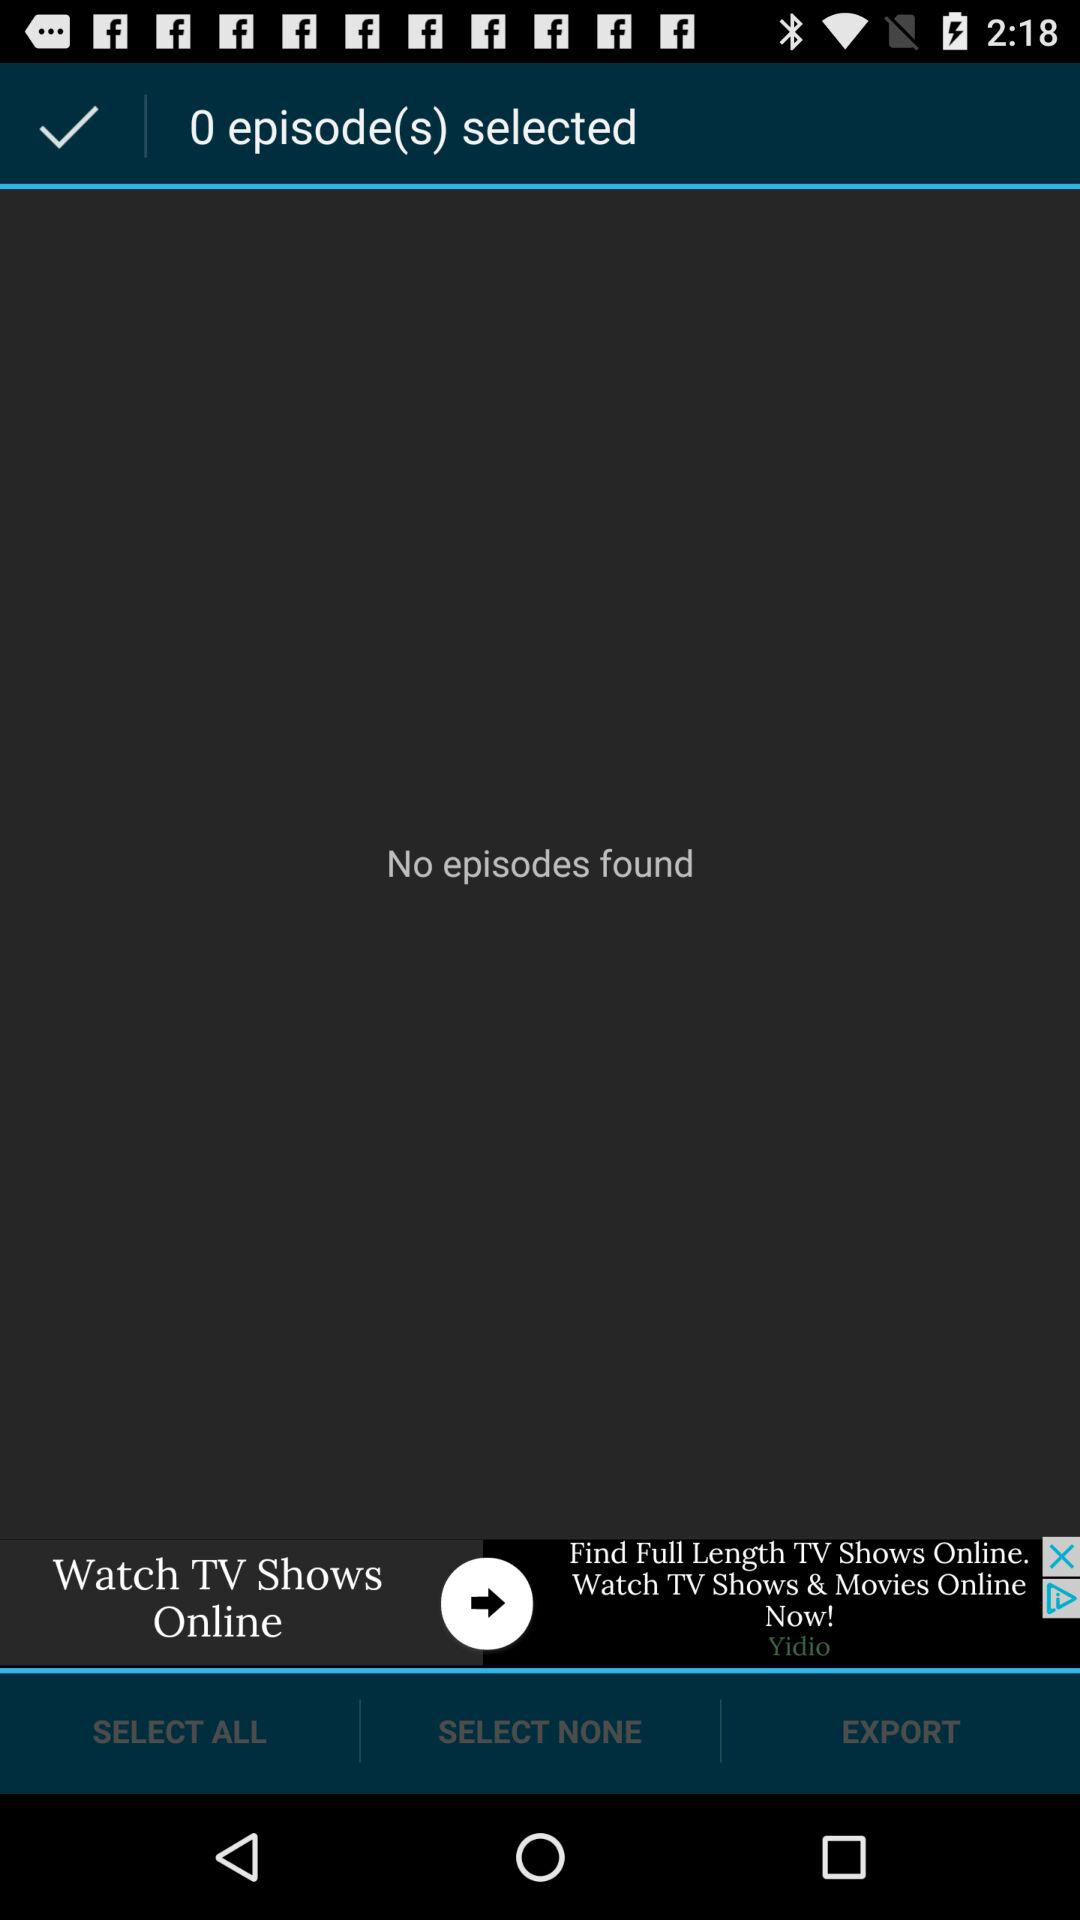How many episodes are selected? There are 0 selected episodes. 